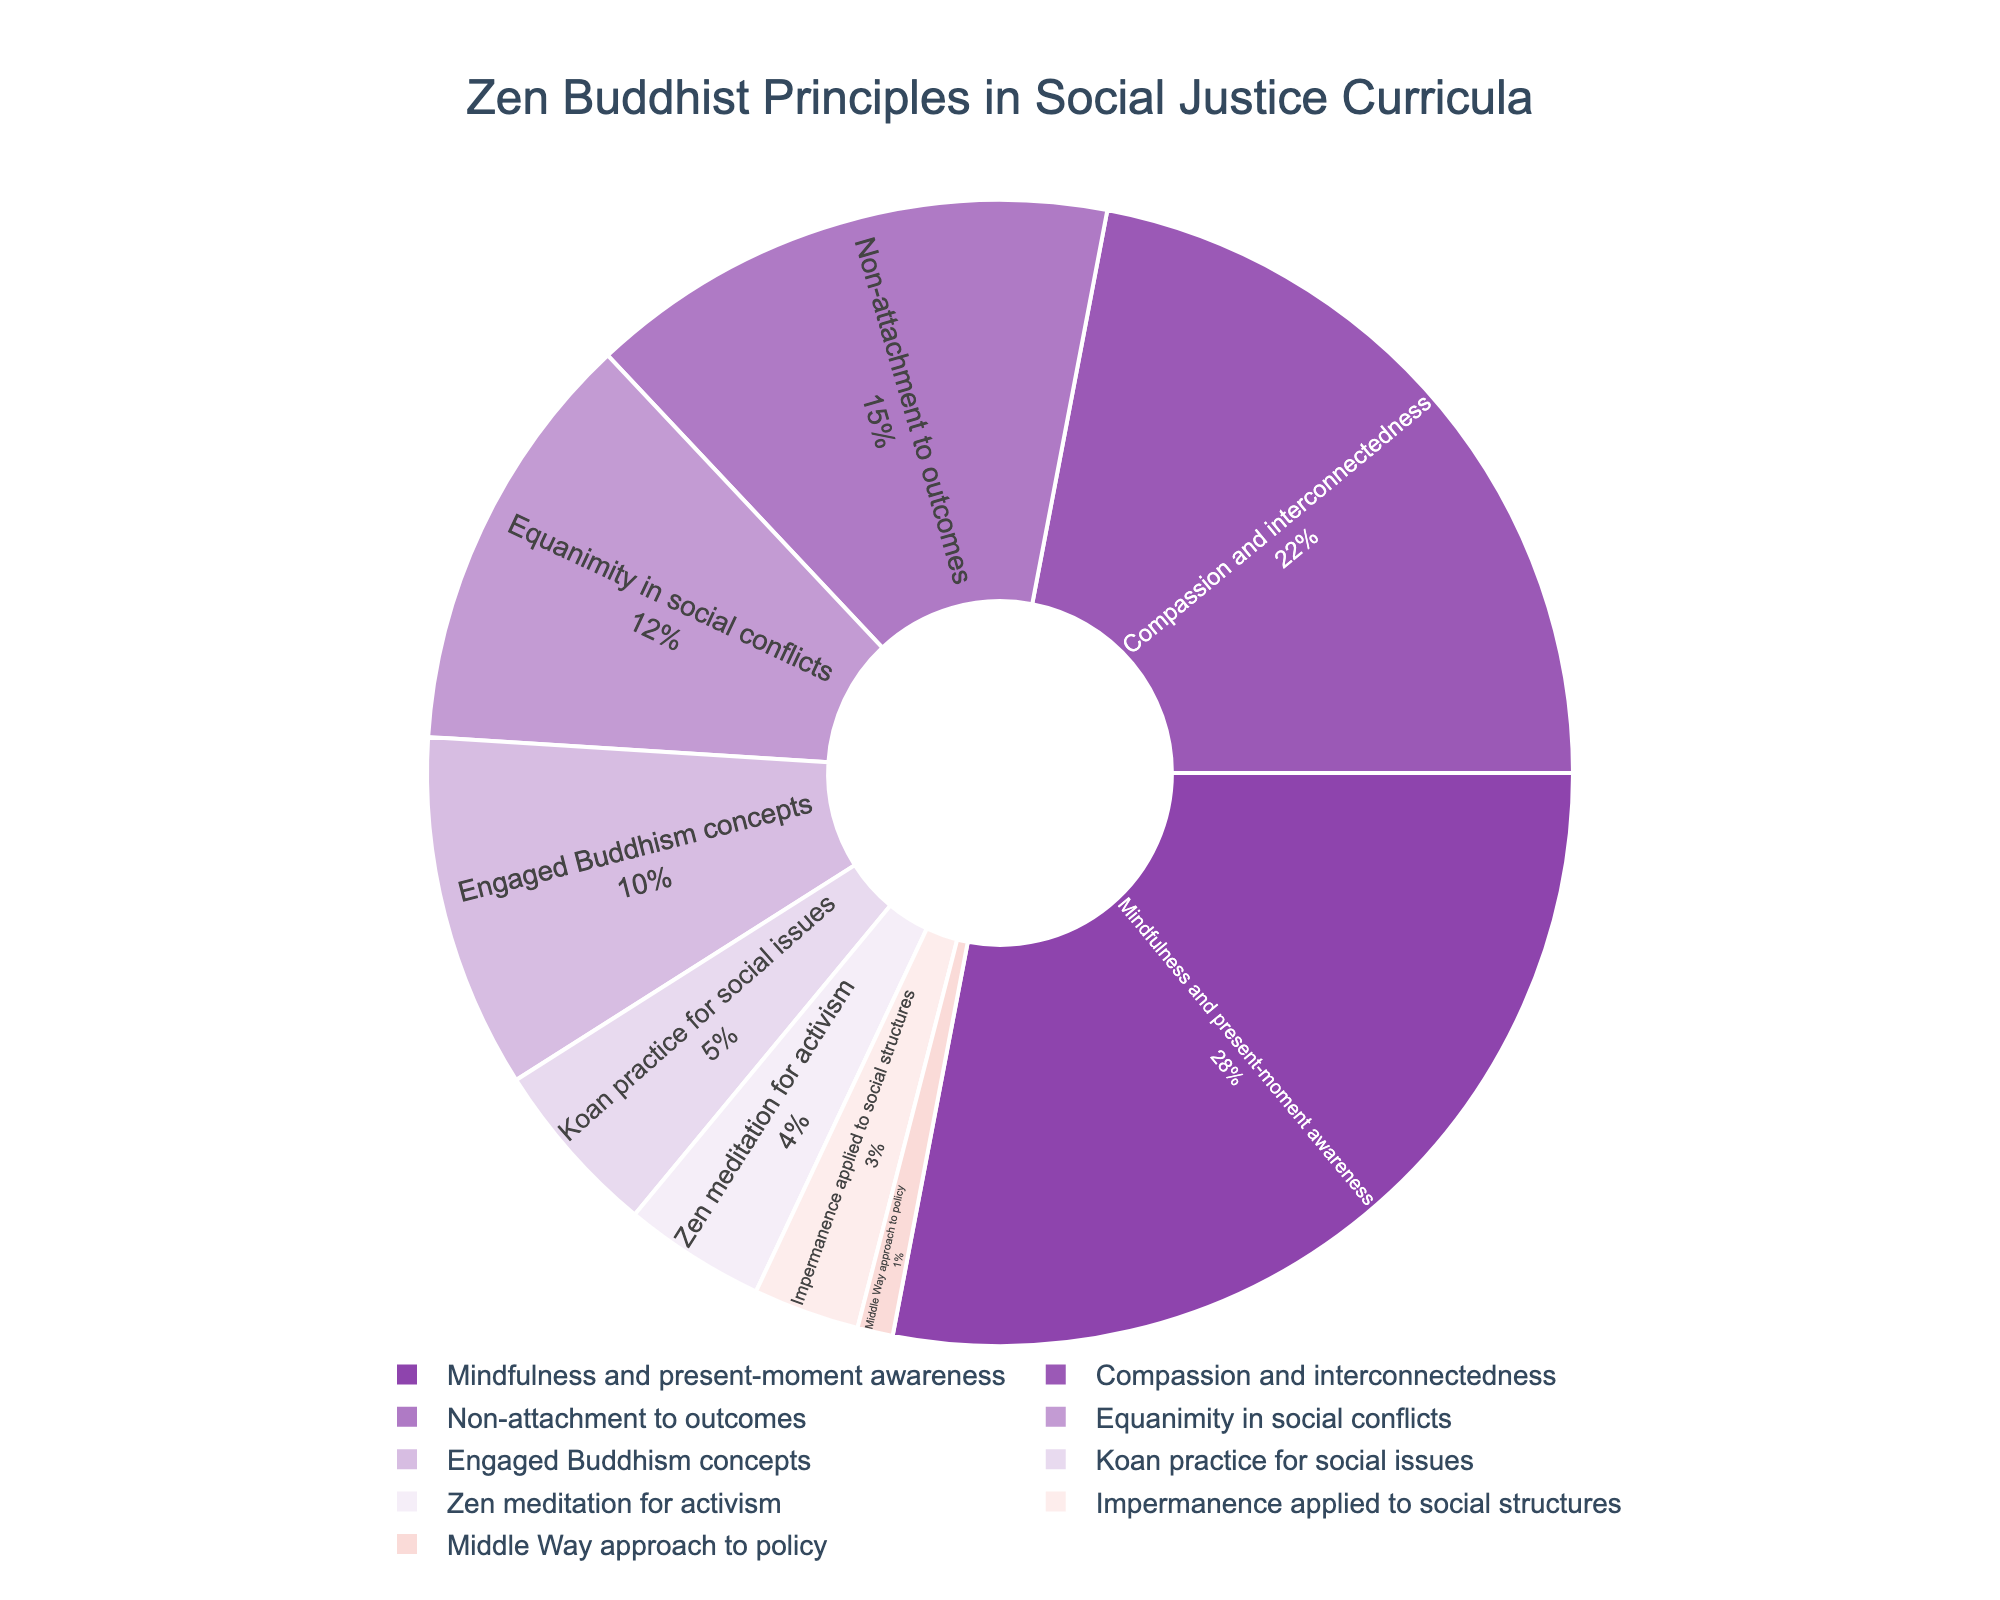What's the most prominent Zen Buddhist principle in social justice curricula? By looking at the pie chart, we see that "Mindfulness and present-moment awareness" takes up the largest section of the pie. It is clearly marked as having 28% of the total.
Answer: Mindfulness and present-moment awareness Which principle is incorporated more, "Non-attachment to outcomes" or "Equanimity in social conflicts"? By comparing their respective portions in the pie chart, we observe that "Non-attachment to outcomes" occupies 15%, while "Equanimity in social conflicts" takes up 12%. Therefore, "Non-attachment to outcomes" is incorporated more.
Answer: Non-attachment to outcomes What's the sum of percentages for "Engaged Buddhism concepts", "Koan practice for social issues", and "Zen meditation for activism"? Looking at the pie chart, we can see that "Engaged Buddhism concepts" is 10%, "Koan practice for social issues" is 5%, and "Zen meditation for activism" is 4%. Summing these values gives 10% + 5% + 4% = 19%.
Answer: 19% Does "Impermanence applied to social structures" take up more or less than 5% of the chart? Examining the pie chart reveals that "Impermanence applied to social structures" holds 3% of the total, which is less than 5%.
Answer: Less How much more prevalent is "Compassion and interconnectedness" compared to the "Middle Way approach to policy"? In the pie chart, "Compassion and interconnectedness" has 22%, and "Middle Way approach to policy" has 1%. The difference between these percentages is 22% - 1% = 21%.
Answer: 21% more What is the combined proportion of the three smallest segments of the pie chart? The three smallest segments in the pie chart represent "Middle Way approach to policy" (1%), "Impermanence applied to social structures" (3%), and "Zen meditation for activism" (4%). Summing these values gives 1% + 3% + 4% = 8%.
Answer: 8% Which principle uses a shade of purple that is more prominent: "Engaged Buddhism concepts" or "Non-attachment to outcomes"? By observing the pie chart, "Engaged Buddhism concepts" is represented by a lighter shade of purple, while "Non-attachment to outcomes" uses a darker, more prominent purple.
Answer: Non-attachment to outcomes What's the difference in percentage points between the two largest principles on the chart? The two largest principles are "Mindfulness and present-moment awareness" (28%) and "Compassion and interconnectedness" (22%). The difference between them is 28% - 22% = 6 percentage points.
Answer: 6 percentage points Is the sum of "Mindfulness and present-moment awareness" and "Compassion and interconnectedness" more than 50% of the total? Adding the percentages for "Mindfulness and present-moment awareness" (28%) and "Compassion and interconnectedness" (22%), we get 28% + 22% = 50%. It is exactly 50%, not more.
Answer: No, it's exactly 50% How does the portion for "Koan practice for social issues" visually compare to the portion for "Middle Way approach to policy"? Observing the chart, "Koan practice for social issues" (5%) is visually larger than the "Middle Way approach to policy" (1%), occupying a far bigger portion of the pie.
Answer: Larger 